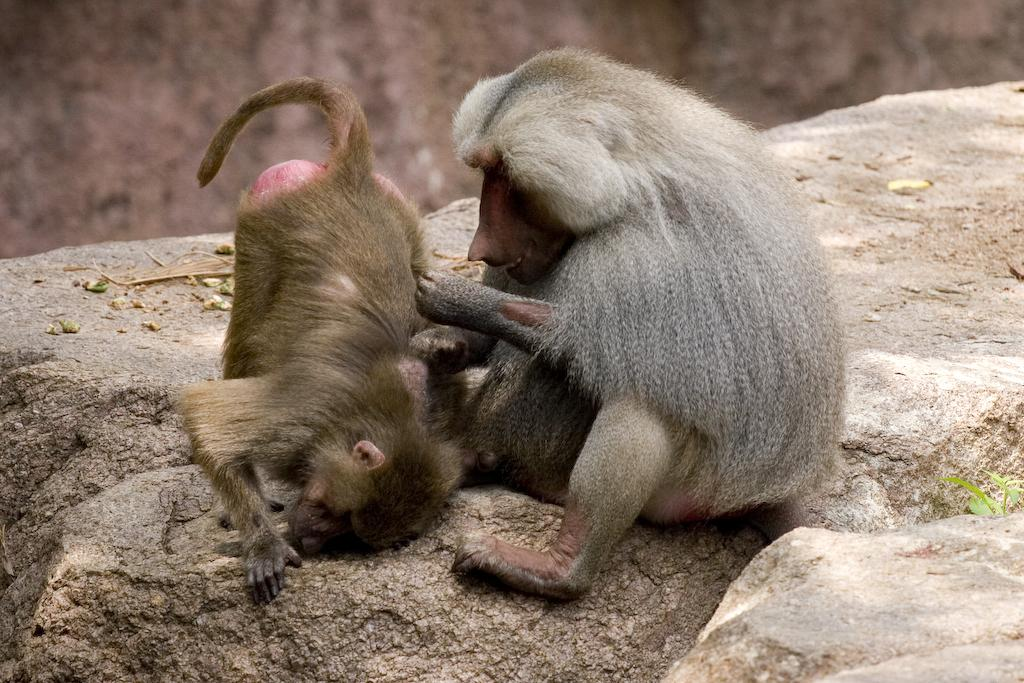How many monkeys are in the image? There are two monkeys in the image. Where are the monkeys located? The monkeys are on rocks. Can you describe the background of the image? The background of the image is blurred. What type of pipe can be seen in the image? There is no pipe present in the image. What request do the monkeys make in the image? The monkeys do not make any requests in the image; they are simply sitting on rocks. 